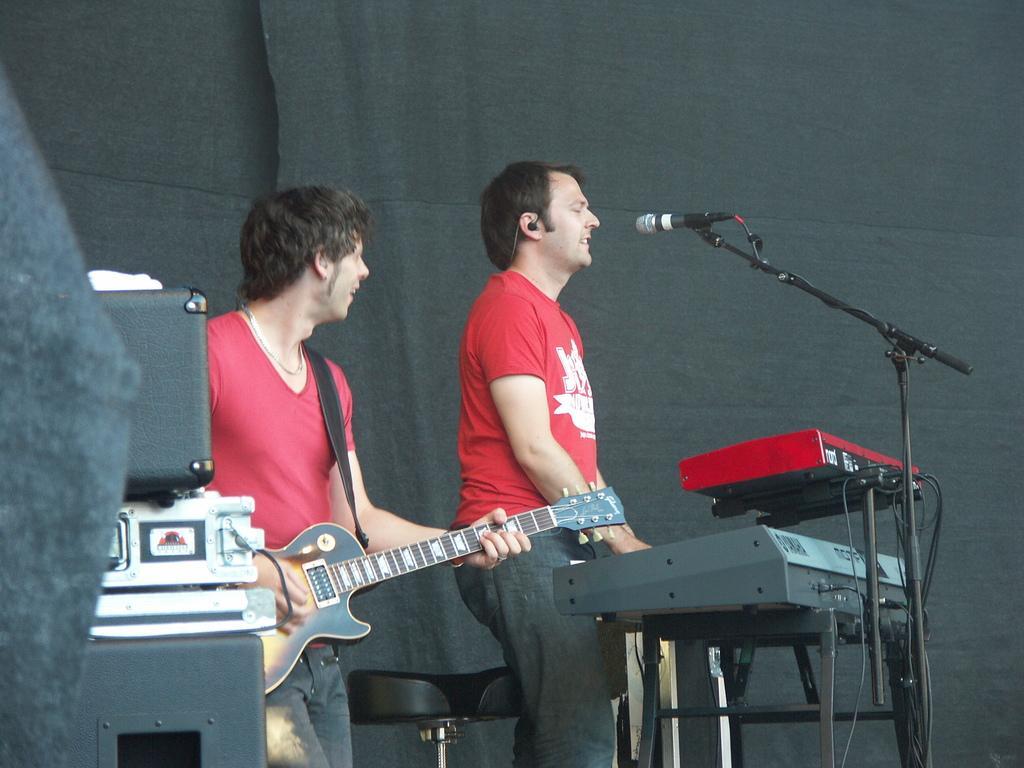Describe this image in one or two sentences. In the center we can see two persons. The left person holding guitar and the right person he is holding key board. in front of him we can see microphone and around the we can see some musical instruments. 